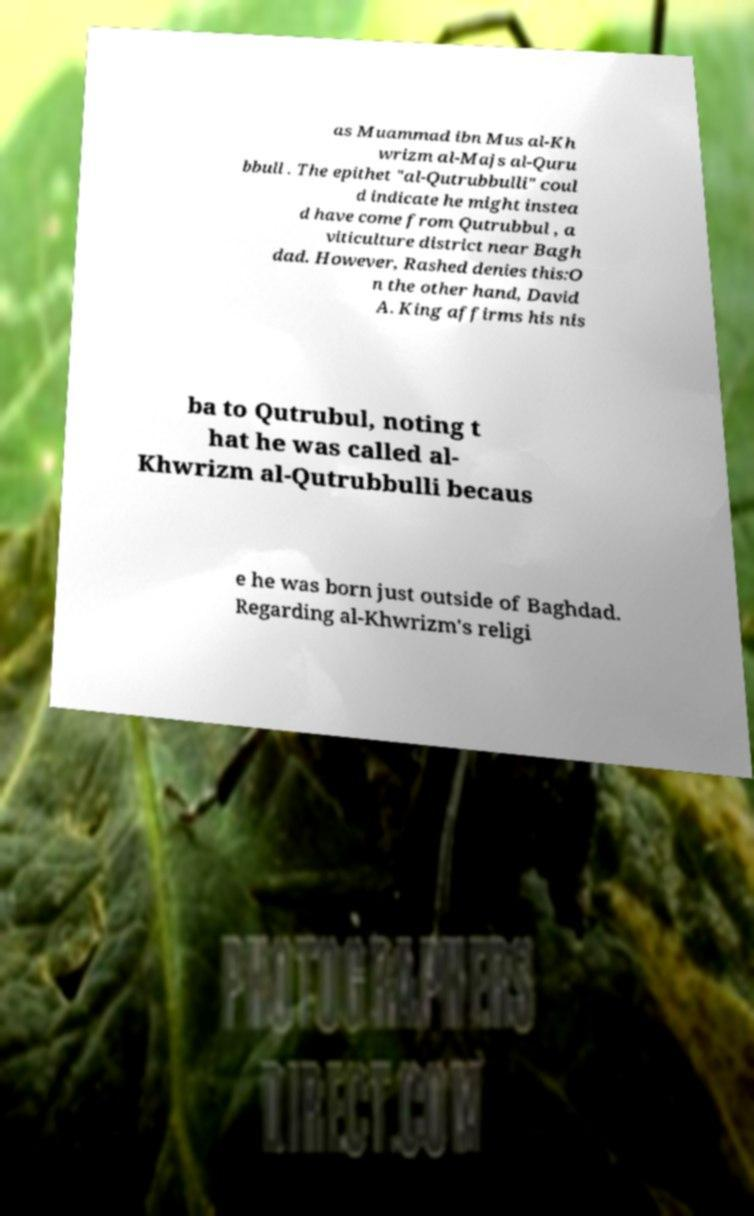Can you read and provide the text displayed in the image?This photo seems to have some interesting text. Can you extract and type it out for me? as Muammad ibn Mus al-Kh wrizm al-Majs al-Quru bbull . The epithet "al-Qutrubbulli" coul d indicate he might instea d have come from Qutrubbul , a viticulture district near Bagh dad. However, Rashed denies this:O n the other hand, David A. King affirms his nis ba to Qutrubul, noting t hat he was called al- Khwrizm al-Qutrubbulli becaus e he was born just outside of Baghdad. Regarding al-Khwrizm's religi 